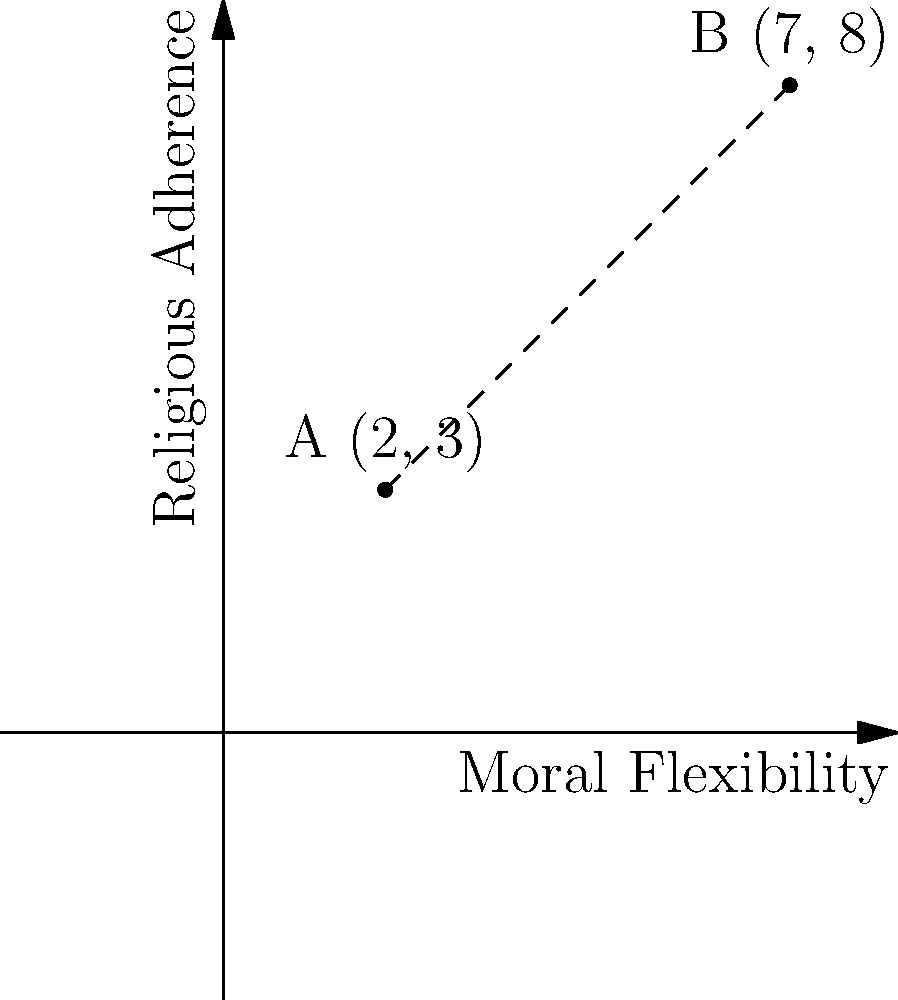A young couple is trying to reconcile their personal beliefs with their religious obligations. On a moral coordinate plane, where the x-axis represents moral flexibility and the y-axis represents religious adherence, two potential moral choices are represented by points A(2, 3) and B(7, 8). Calculate the distance between these two moral choices to help the couple understand the magnitude of their decision. To find the distance between two points on a coordinate plane, we can use the distance formula:

$$d = \sqrt{(x_2 - x_1)^2 + (y_2 - y_1)^2}$$

Where $(x_1, y_1)$ represents the coordinates of point A, and $(x_2, y_2)$ represents the coordinates of point B.

Step 1: Identify the coordinates
Point A: $(2, 3)$
Point B: $(7, 8)$

Step 2: Substitute the values into the distance formula
$$d = \sqrt{(7 - 2)^2 + (8 - 3)^2}$$

Step 3: Simplify the expressions inside the parentheses
$$d = \sqrt{5^2 + 5^2}$$

Step 4: Calculate the squares
$$d = \sqrt{25 + 25}$$

Step 5: Add the values under the square root
$$d = \sqrt{50}$$

Step 6: Simplify the square root
$$d = 5\sqrt{2}$$

Therefore, the distance between the two moral choices is $5\sqrt{2}$ units.
Answer: $5\sqrt{2}$ units 